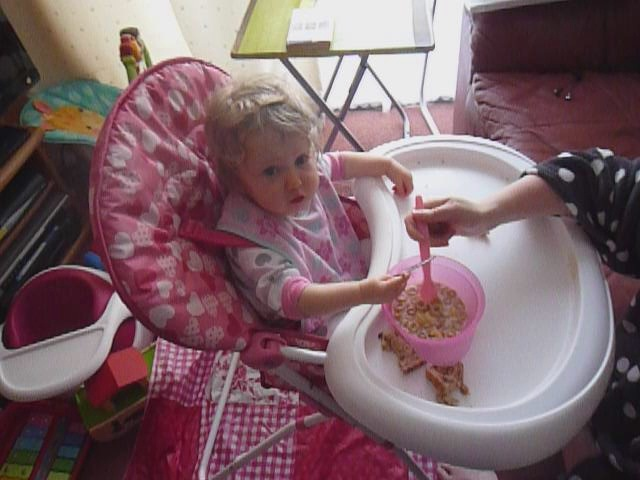Describe the objects in this image and their specific colors. I can see chair in brown and maroon tones, people in brown, gray, maroon, and darkgray tones, couch in brown, black, and maroon tones, people in brown, black, maroon, and gray tones, and dining table in brown, lightgray, gray, darkgray, and khaki tones in this image. 